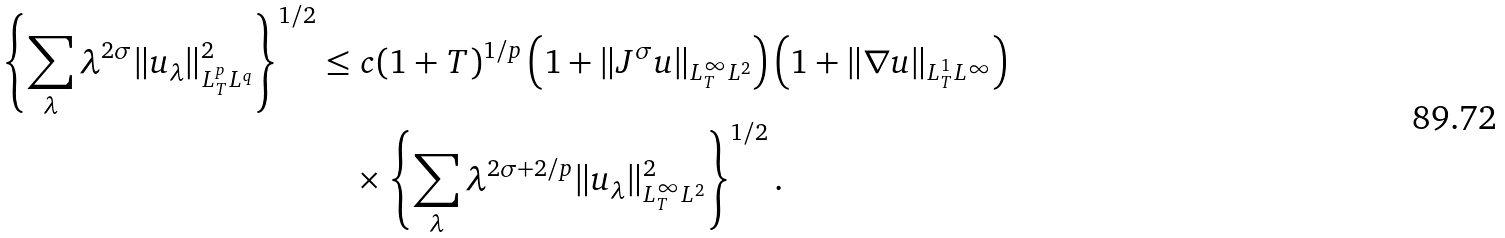Convert formula to latex. <formula><loc_0><loc_0><loc_500><loc_500>\left \{ \sum _ { \lambda } \lambda ^ { 2 \sigma } \| u _ { \lambda } \| ^ { 2 } _ { L ^ { p } _ { T } L ^ { q } } \right \} ^ { 1 / 2 } \leq & \ c ( 1 + T ) ^ { 1 / p } \left ( 1 + \| J ^ { \sigma } u \| _ { L ^ { \infty } _ { T } L ^ { 2 } } \right ) \left ( 1 + \| \nabla u \| _ { L ^ { 1 } _ { T } L ^ { \infty } } \right ) \\ & \times \left \{ \sum _ { \lambda } \lambda ^ { 2 \sigma + 2 / p } \| u _ { \lambda } \| ^ { 2 } _ { L ^ { \infty } _ { T } L ^ { 2 } } \right \} ^ { 1 / 2 } .</formula> 